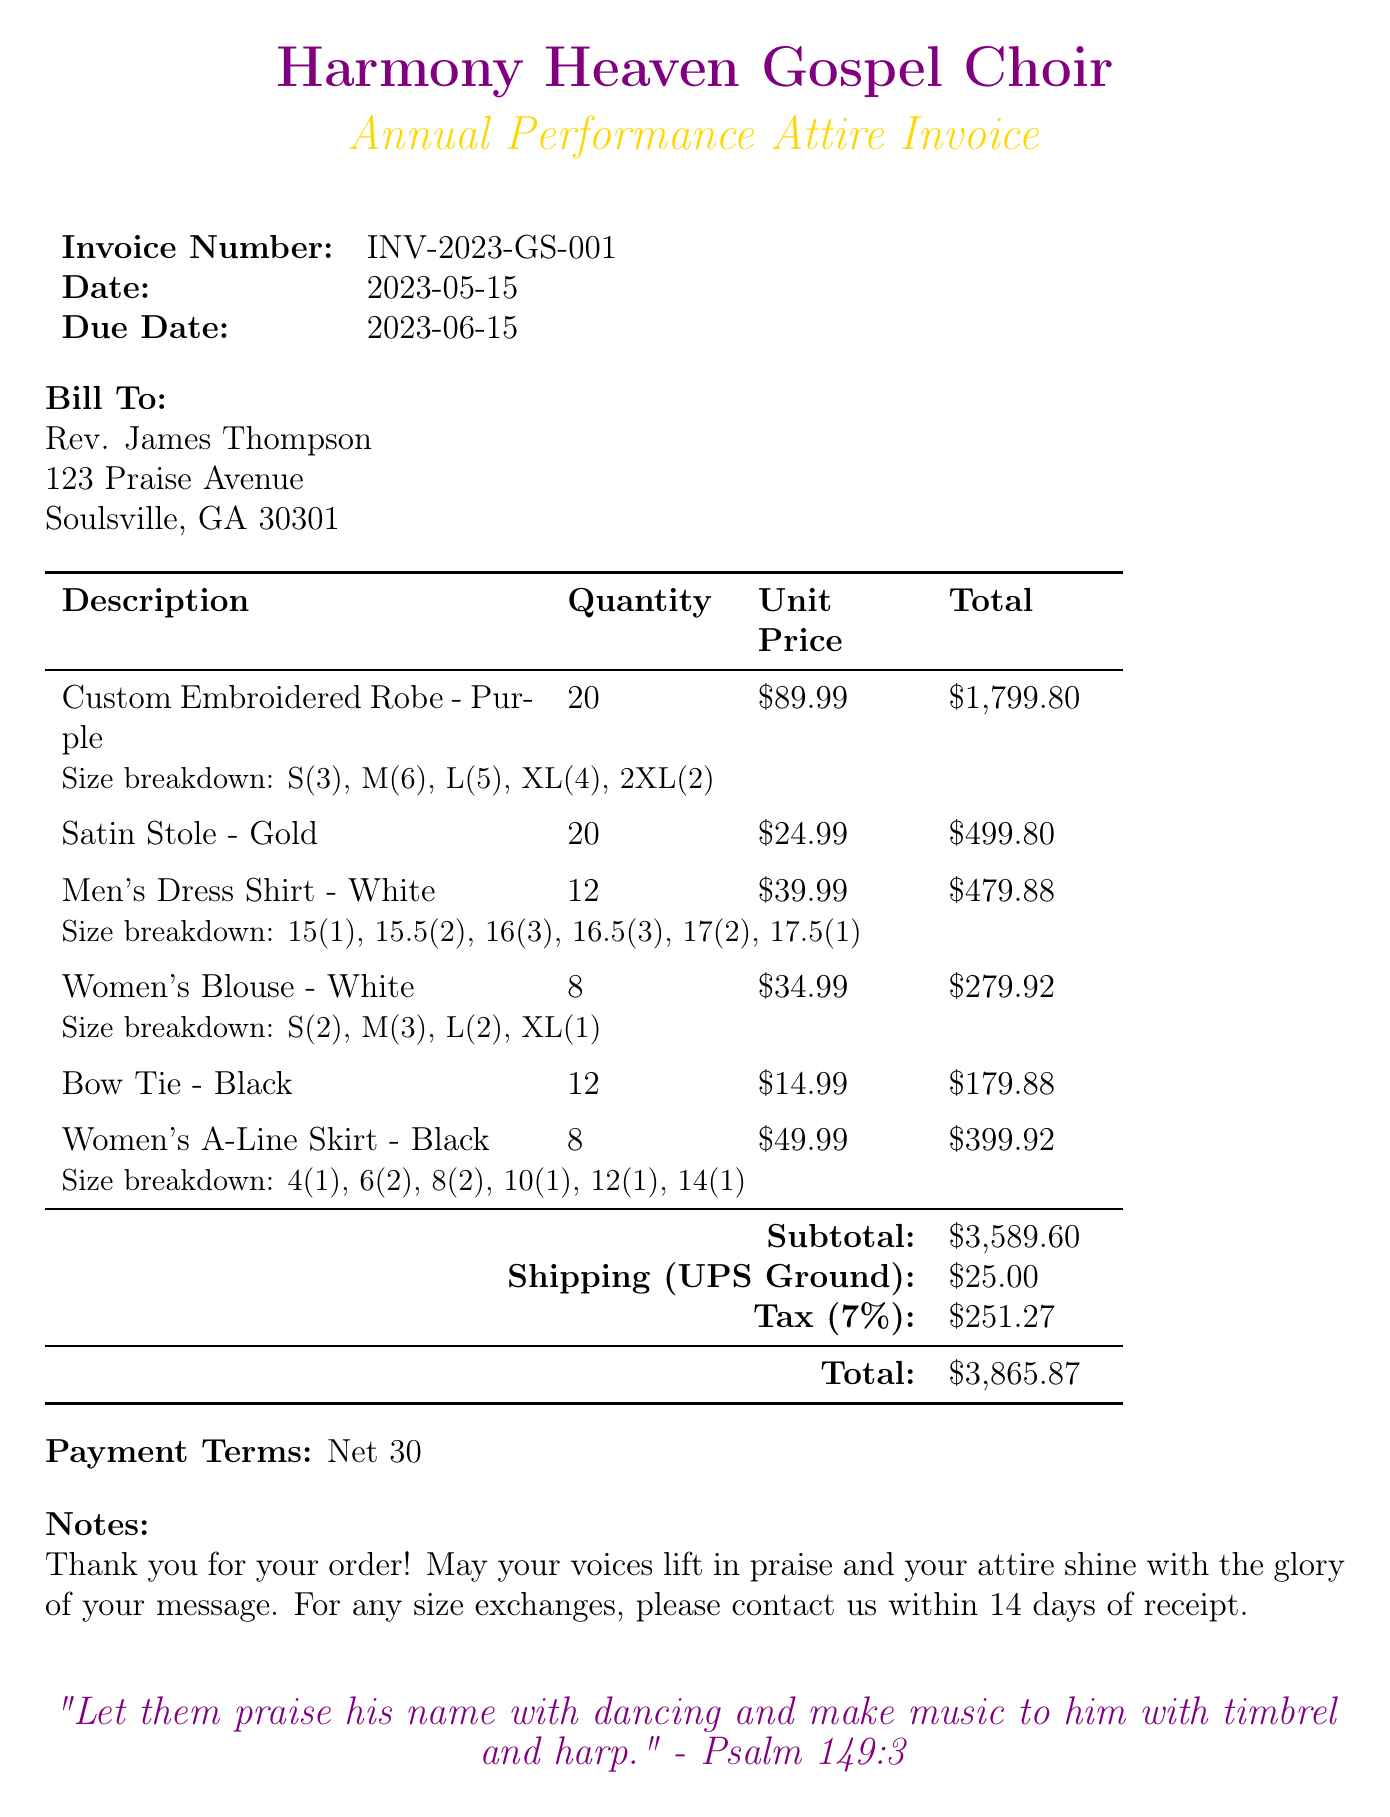What is the invoice number? The invoice number is a unique identifier for the document provided, which is listed as INV-2023-GS-001.
Answer: INV-2023-GS-001 What is the total amount due? The total amount is the final amount that includes the subtotal, shipping, and tax, which is specified as $3,865.87.
Answer: $3,865.87 What is the due date for payment? The due date is when payment is expected, which is clearly stated as 2023-06-15.
Answer: 2023-06-15 How many Custom Embroidered Robes were ordered? The quantity of Custom Embroidered Robes requested is specified in the items section, which states 20.
Answer: 20 What brand makes the Women's Blouse? The brand is indicated next to the description of the item in the document, which is Graceful Garments.
Answer: Graceful Garments How much is the shipping cost? The shipping cost is detailed separately in the invoice, which amounts to $25.00.
Answer: $25.00 What size has the highest quantity for Women's Blouse? A size breakdown provides the quantities, with M at 3 being the highest for the Women's Blouse.
Answer: M What is the tax percentage applied to the invoice? The document specifies tax, which is indicated as 7%.
Answer: 7% Who is the invoice billed to? The billing information includes the name of the individual or entity, which is Rev. James Thompson.
Answer: Rev. James Thompson 